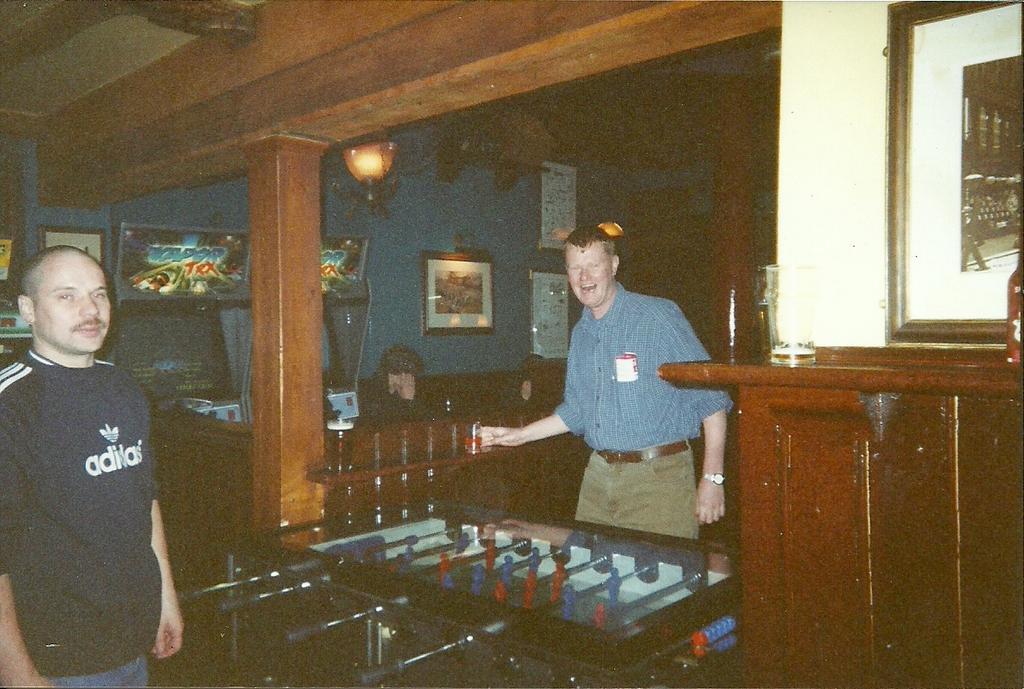Describe this image in one or two sentences. They both are standing. On the right side we have a blue color shirt person. He's wearing a watch. We can see in the background there is a cupboard,pillar,photo albums on lights. 